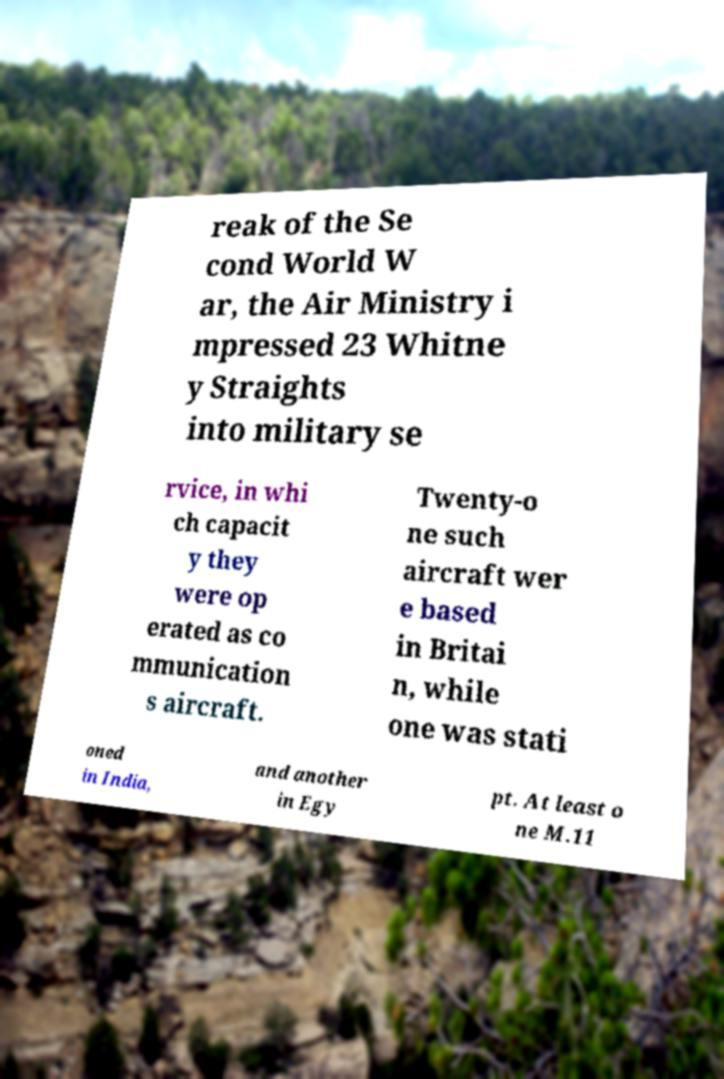What messages or text are displayed in this image? I need them in a readable, typed format. reak of the Se cond World W ar, the Air Ministry i mpressed 23 Whitne y Straights into military se rvice, in whi ch capacit y they were op erated as co mmunication s aircraft. Twenty-o ne such aircraft wer e based in Britai n, while one was stati oned in India, and another in Egy pt. At least o ne M.11 